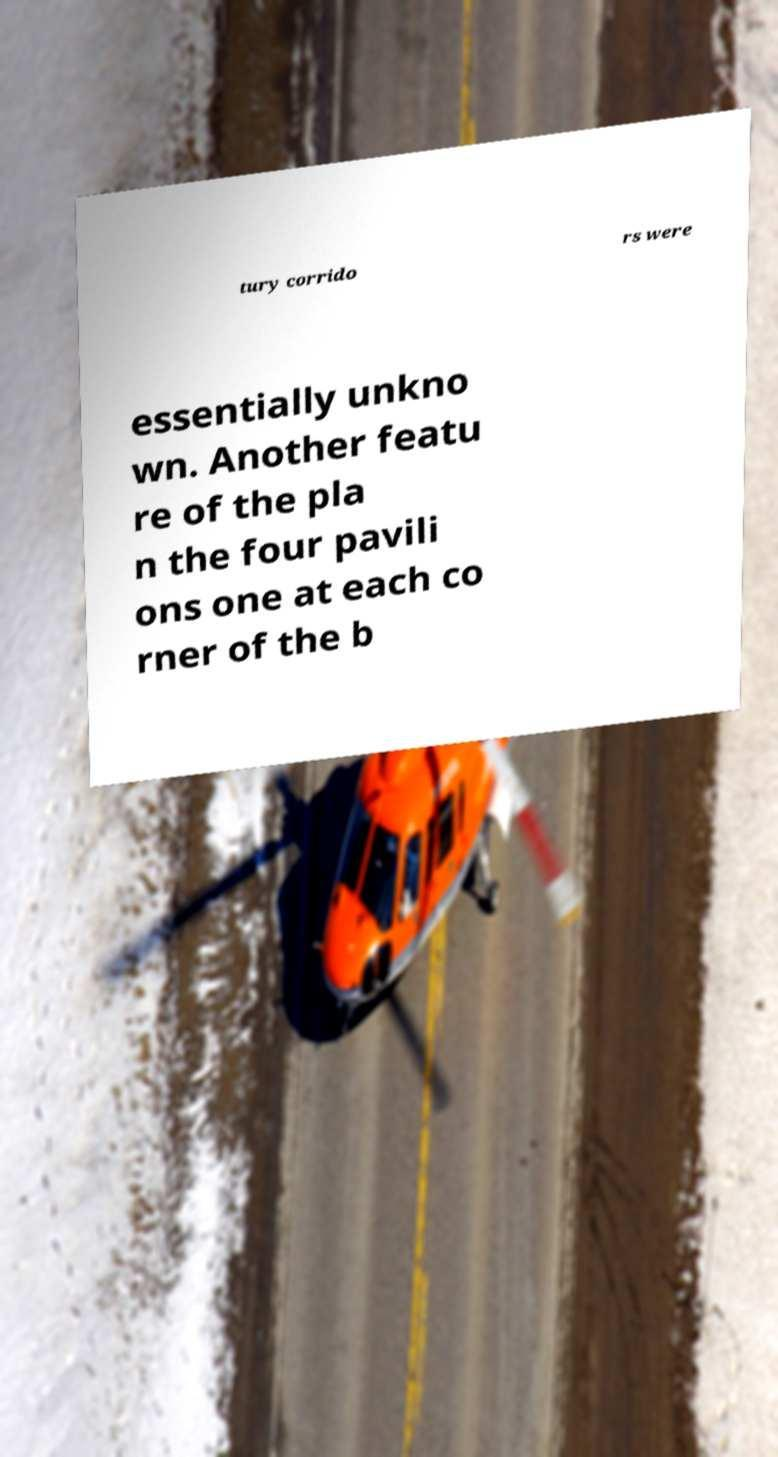Please read and relay the text visible in this image. What does it say? tury corrido rs were essentially unkno wn. Another featu re of the pla n the four pavili ons one at each co rner of the b 